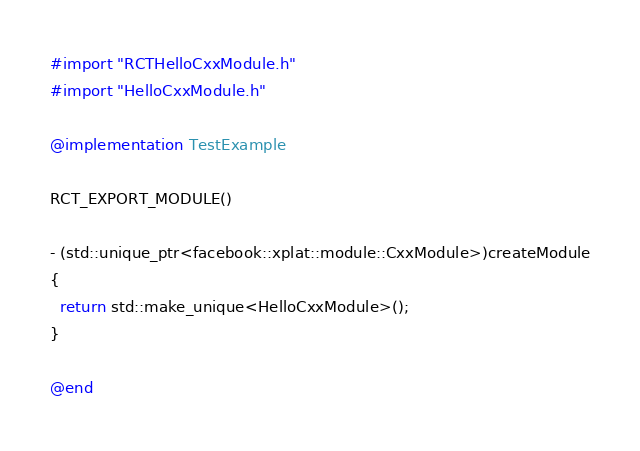Convert code to text. <code><loc_0><loc_0><loc_500><loc_500><_ObjectiveC_>#import "RCTHelloCxxModule.h"
#import "HelloCxxModule.h"

@implementation TestExample

RCT_EXPORT_MODULE()

- (std::unique_ptr<facebook::xplat::module::CxxModule>)createModule
{
  return std::make_unique<HelloCxxModule>();
}

@end
</code> 